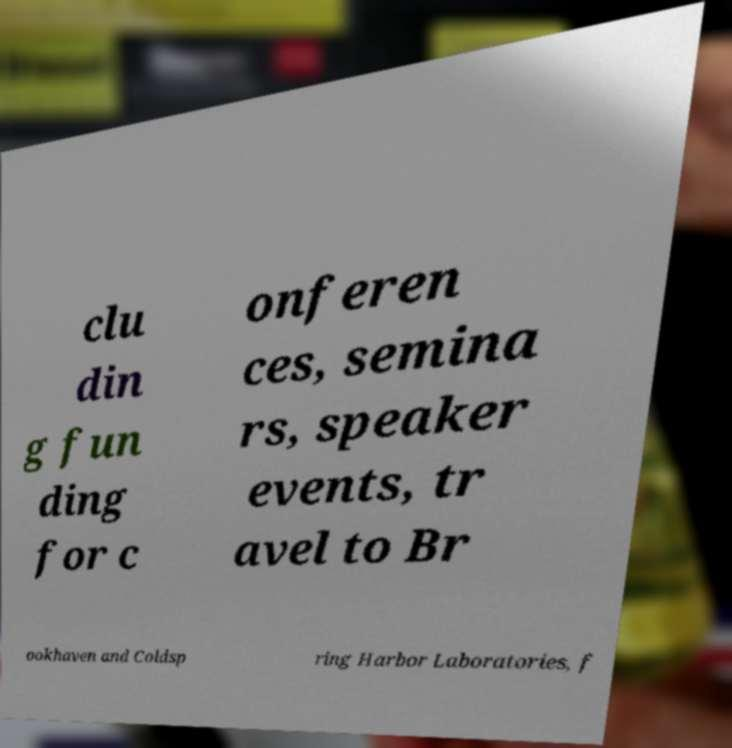Can you read and provide the text displayed in the image?This photo seems to have some interesting text. Can you extract and type it out for me? clu din g fun ding for c onferen ces, semina rs, speaker events, tr avel to Br ookhaven and Coldsp ring Harbor Laboratories, f 